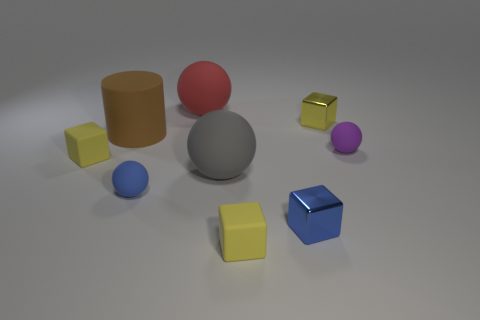There is a cube on the left side of the gray matte ball; what is its color?
Make the answer very short. Yellow. Is the purple rubber thing the same shape as the red thing?
Keep it short and to the point. Yes. The matte thing that is in front of the large gray sphere and right of the gray rubber ball is what color?
Ensure brevity in your answer.  Yellow. Do the yellow rubber thing that is right of the blue rubber thing and the shiny block that is behind the large brown matte cylinder have the same size?
Make the answer very short. Yes. What number of objects are tiny rubber cubes that are on the right side of the large red sphere or yellow things?
Your answer should be very brief. 3. What is the material of the cylinder?
Offer a very short reply. Rubber. Is the size of the gray rubber thing the same as the blue shiny object?
Give a very brief answer. No. What number of cubes are either big red matte objects or gray rubber things?
Ensure brevity in your answer.  0. What color is the big rubber ball in front of the rubber thing left of the large brown rubber thing?
Your answer should be compact. Gray. Is the number of large brown matte cylinders that are behind the red matte object less than the number of shiny cubes that are on the right side of the blue matte ball?
Give a very brief answer. Yes. 